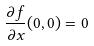<formula> <loc_0><loc_0><loc_500><loc_500>\frac { \partial f } { \partial x } ( 0 , 0 ) = 0</formula> 